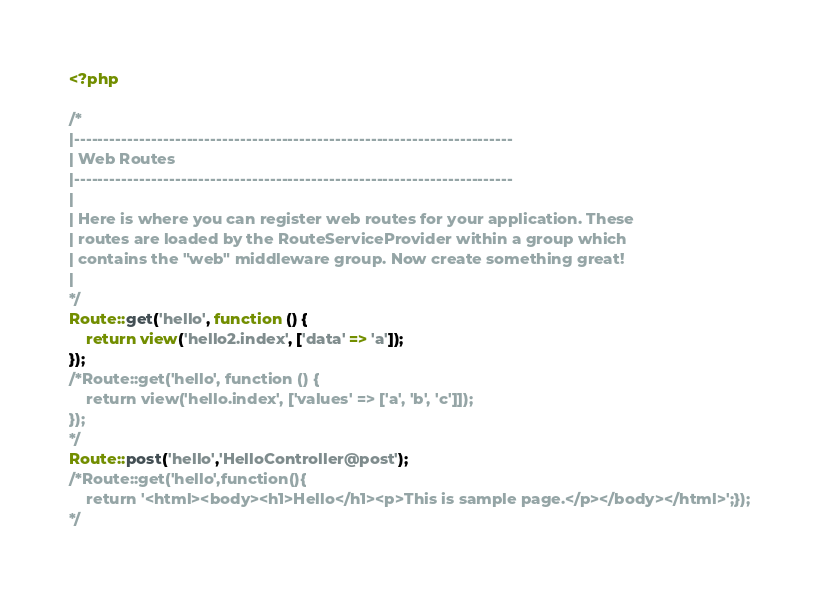<code> <loc_0><loc_0><loc_500><loc_500><_PHP_><?php

/*
|--------------------------------------------------------------------------
| Web Routes
|--------------------------------------------------------------------------
|
| Here is where you can register web routes for your application. These
| routes are loaded by the RouteServiceProvider within a group which
| contains the "web" middleware group. Now create something great!
|
*/
Route::get('hello', function () {
    return view('hello2.index', ['data' => 'a']);
});
/*Route::get('hello', function () {
    return view('hello.index', ['values' => ['a', 'b', 'c']]);
});
*/
Route::post('hello','HelloController@post');
/*Route::get('hello',function(){
    return '<html><body><h1>Hello</h1><p>This is sample page.</p></body></html>';});
*/

</code> 